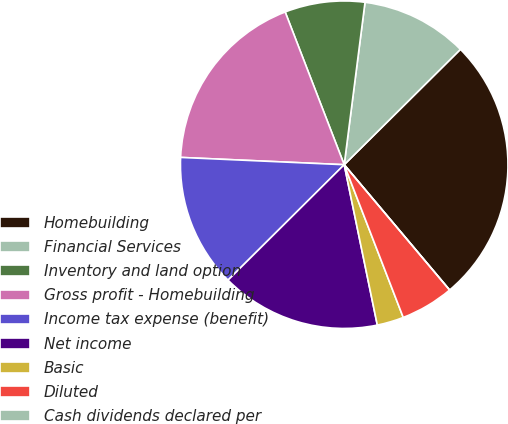Convert chart. <chart><loc_0><loc_0><loc_500><loc_500><pie_chart><fcel>Homebuilding<fcel>Financial Services<fcel>Inventory and land option<fcel>Gross profit - Homebuilding<fcel>Income tax expense (benefit)<fcel>Net income<fcel>Basic<fcel>Diluted<fcel>Cash dividends declared per<nl><fcel>26.31%<fcel>10.53%<fcel>7.9%<fcel>18.42%<fcel>13.16%<fcel>15.79%<fcel>2.63%<fcel>5.26%<fcel>0.0%<nl></chart> 